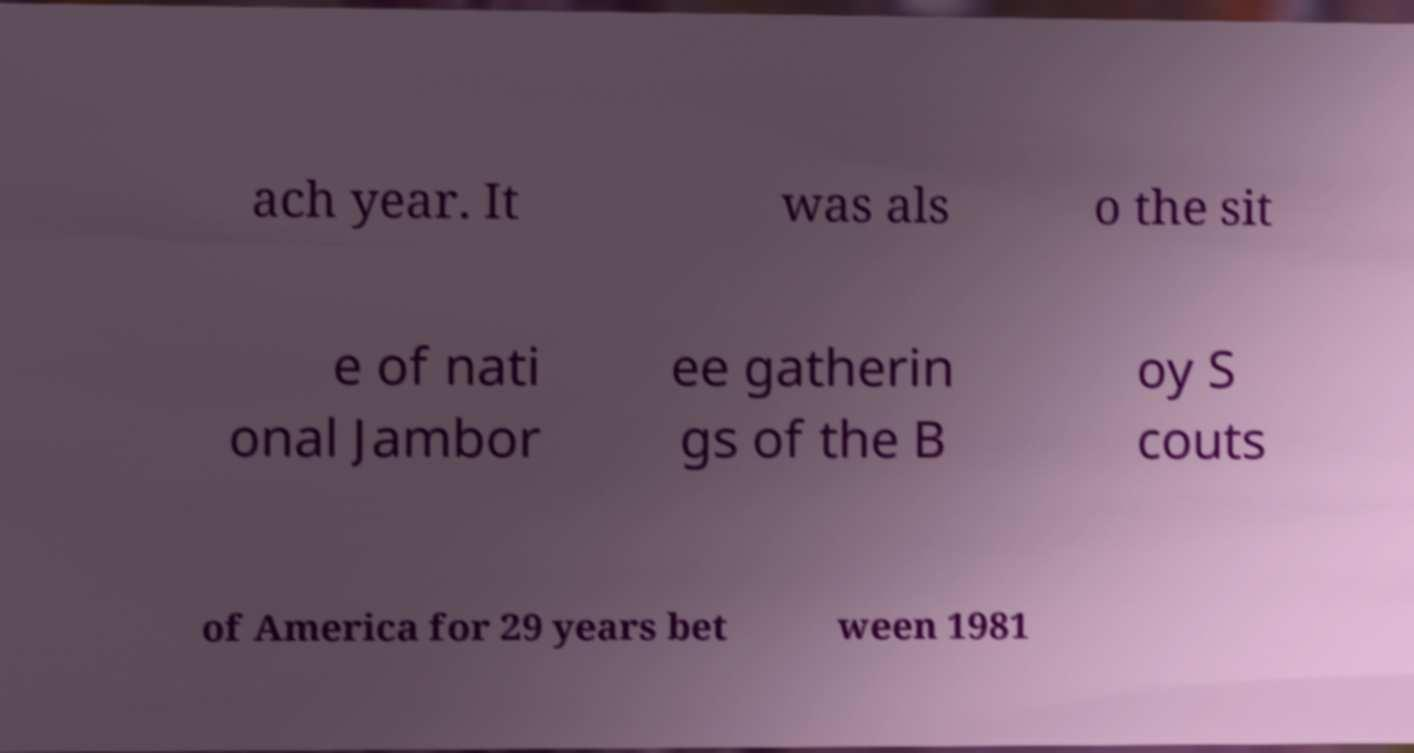What messages or text are displayed in this image? I need them in a readable, typed format. ach year. It was als o the sit e of nati onal Jambor ee gatherin gs of the B oy S couts of America for 29 years bet ween 1981 